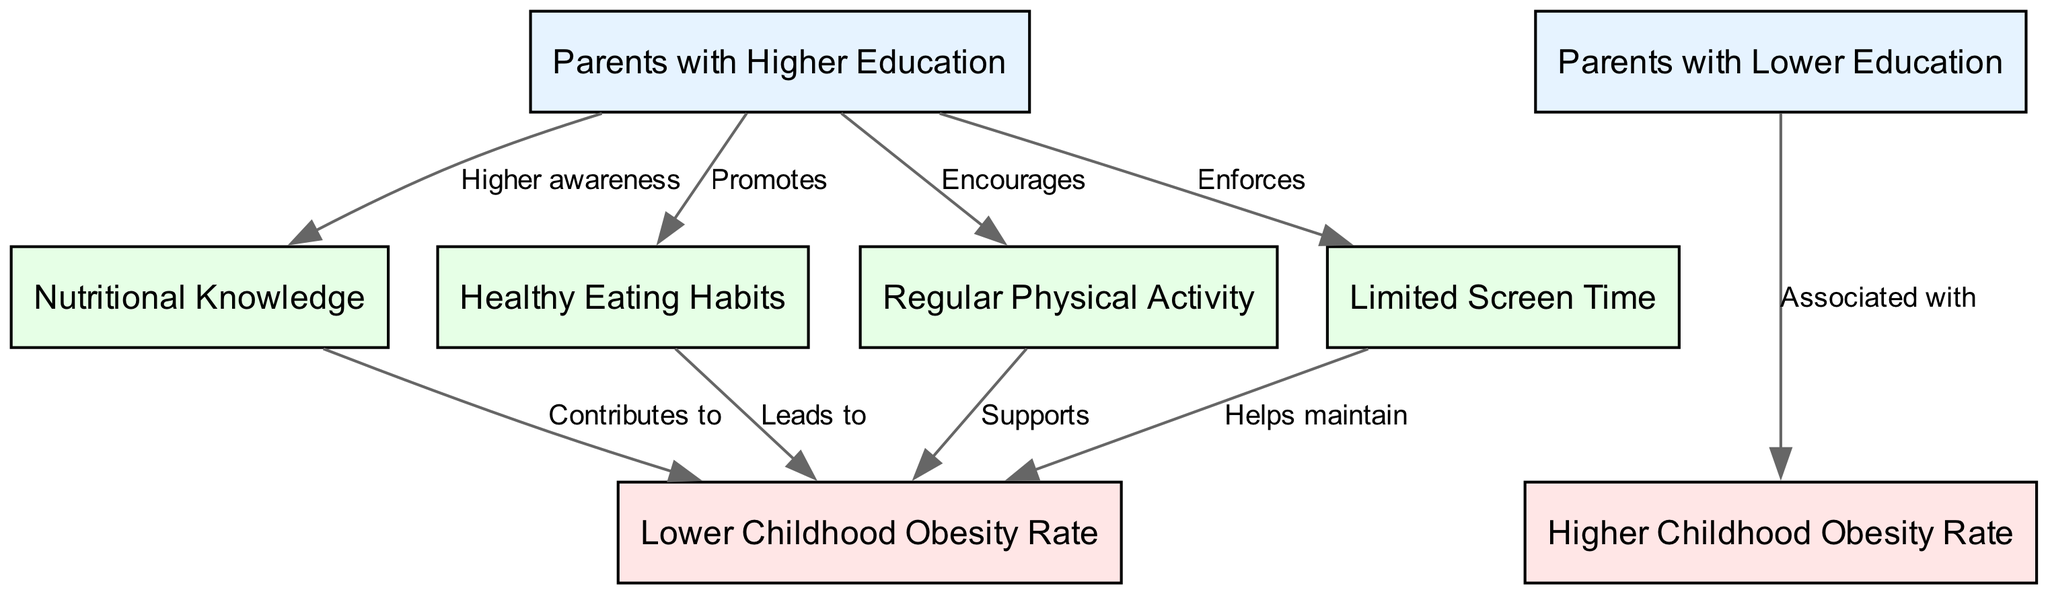What is the total number of nodes in the diagram? The diagram lists eight different nodes representing groups, factors, and outcomes. By counting each node in the provided data, we identify that there are eight nodes.
Answer: 8 What type of relationship exists between "Parents with Higher Education" and "Nutritional Knowledge"? The edge from "Parents with Higher Education" to "Nutritional Knowledge" is labeled "Higher awareness," indicating a positive influence or informative relationship.
Answer: Higher awareness How many outcomes are represented in the diagram? The diagram provides two outcomes: "Lower Childhood Obesity Rate" and "Higher Childhood Obesity Rate." Counting these reveals there are two outcomes present.
Answer: 2 What does "Healthy Eating Habits" contribute to? The arrow connecting "Healthy Eating Habits" leads directly to "Lower Childhood Obesity Rate," with the label "Leads to," indicating that this factor is beneficial against obesity.
Answer: Lower Childhood Obesity Rate What is the relationship between "Parents with Lower Education" and "Higher Childhood Obesity Rate"? The edge from "Parents with Lower Education" to "Higher Childhood Obesity Rate" is labeled "Associated with," suggesting that lower education levels correspond to increased obesity rates among children.
Answer: Associated with Which factor is indicated as "Helps maintain"? The edge leading from "Limited Screen Time" points to "Lower Childhood Obesity Rate," marked with the label "Helps maintain," indicating its role in preventing obesity.
Answer: Lower Childhood Obesity Rate What type of influence does "Regular Physical Activity" have on childhood obesity rates? The edge from "Regular Physical Activity" to "Lower Childhood Obesity Rate" is labeled "Supports," suggesting it positively affects reducing obesity rates.
Answer: Supports How many edges connect nodes from "Parents with Higher Education" to outcomes? Counting the edges connected to the outcomes from "Parents with Higher Education," there are four direct connections to outcome nodes regarding their outcomes, mainly towards "Lower Childhood Obesity Rate."
Answer: 4 